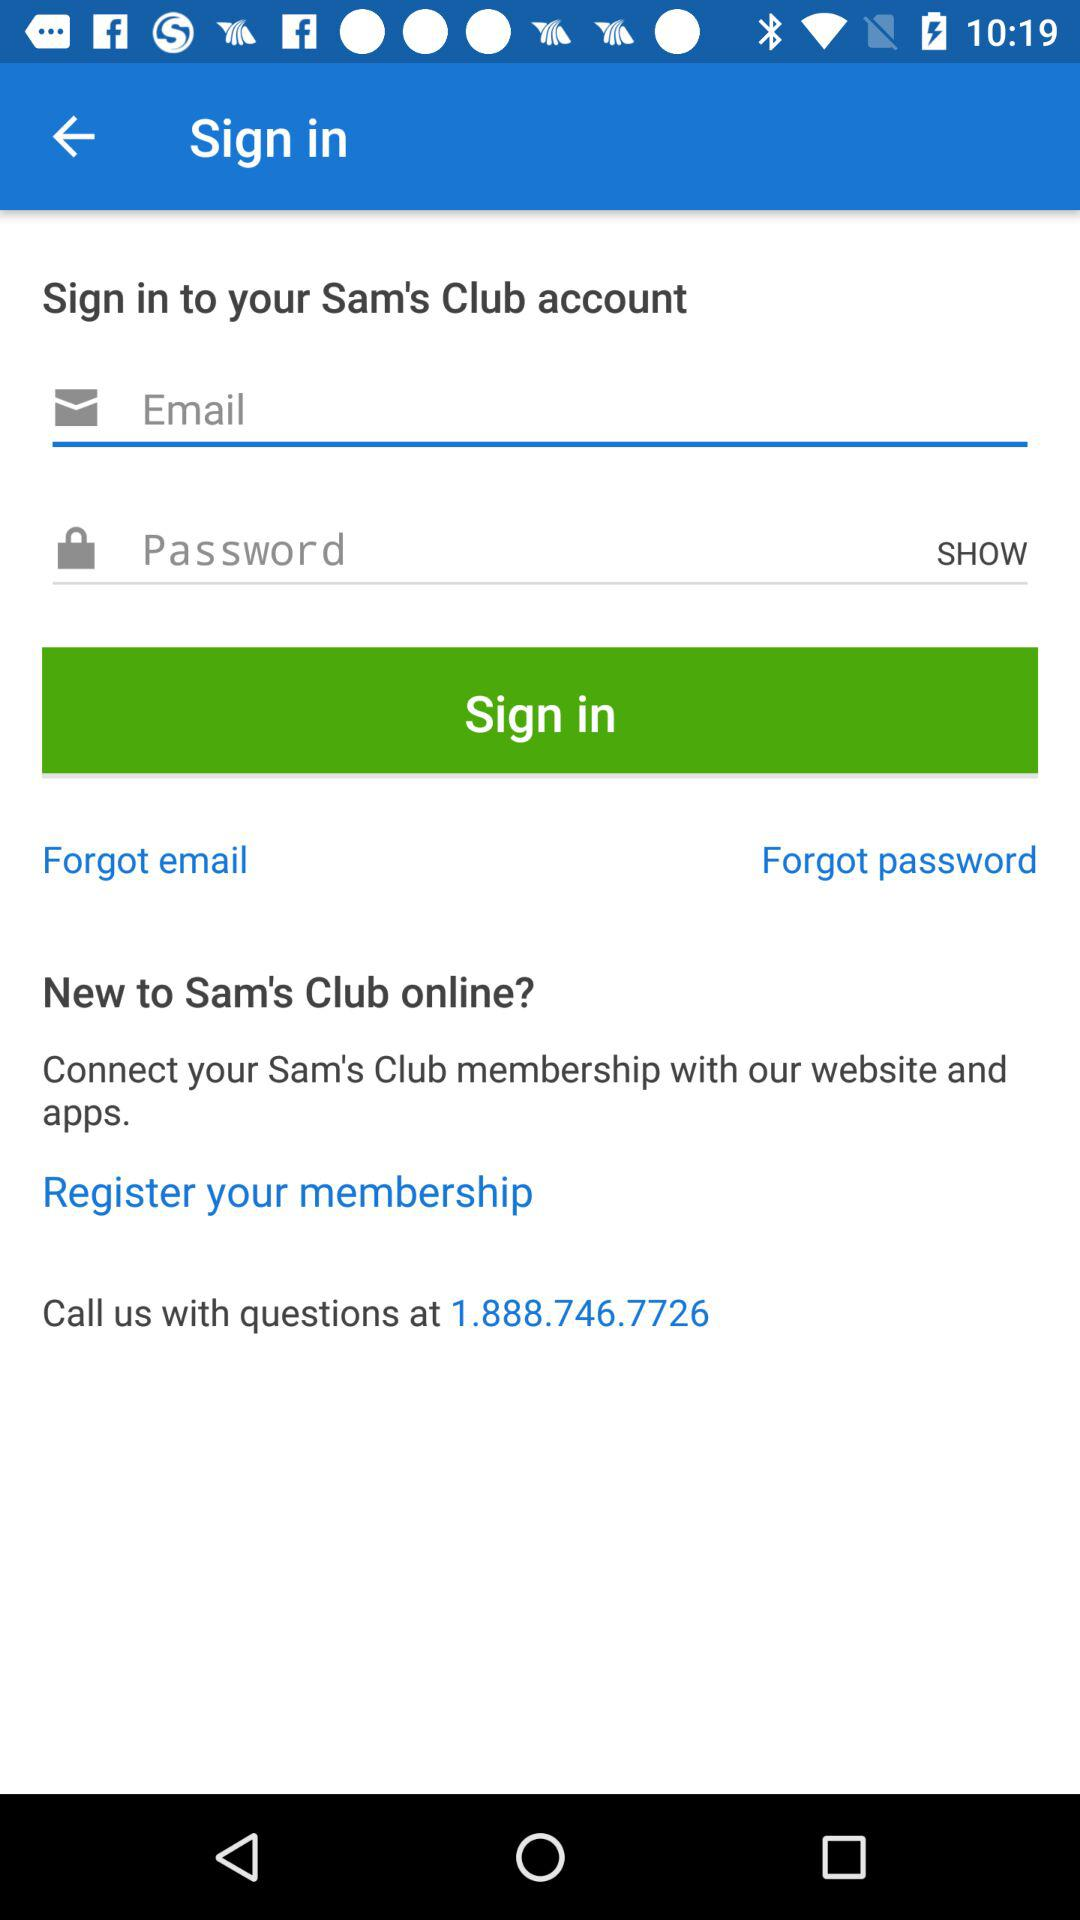What is the contact number to call with questions? The contact number is 1.888.746.7726. 